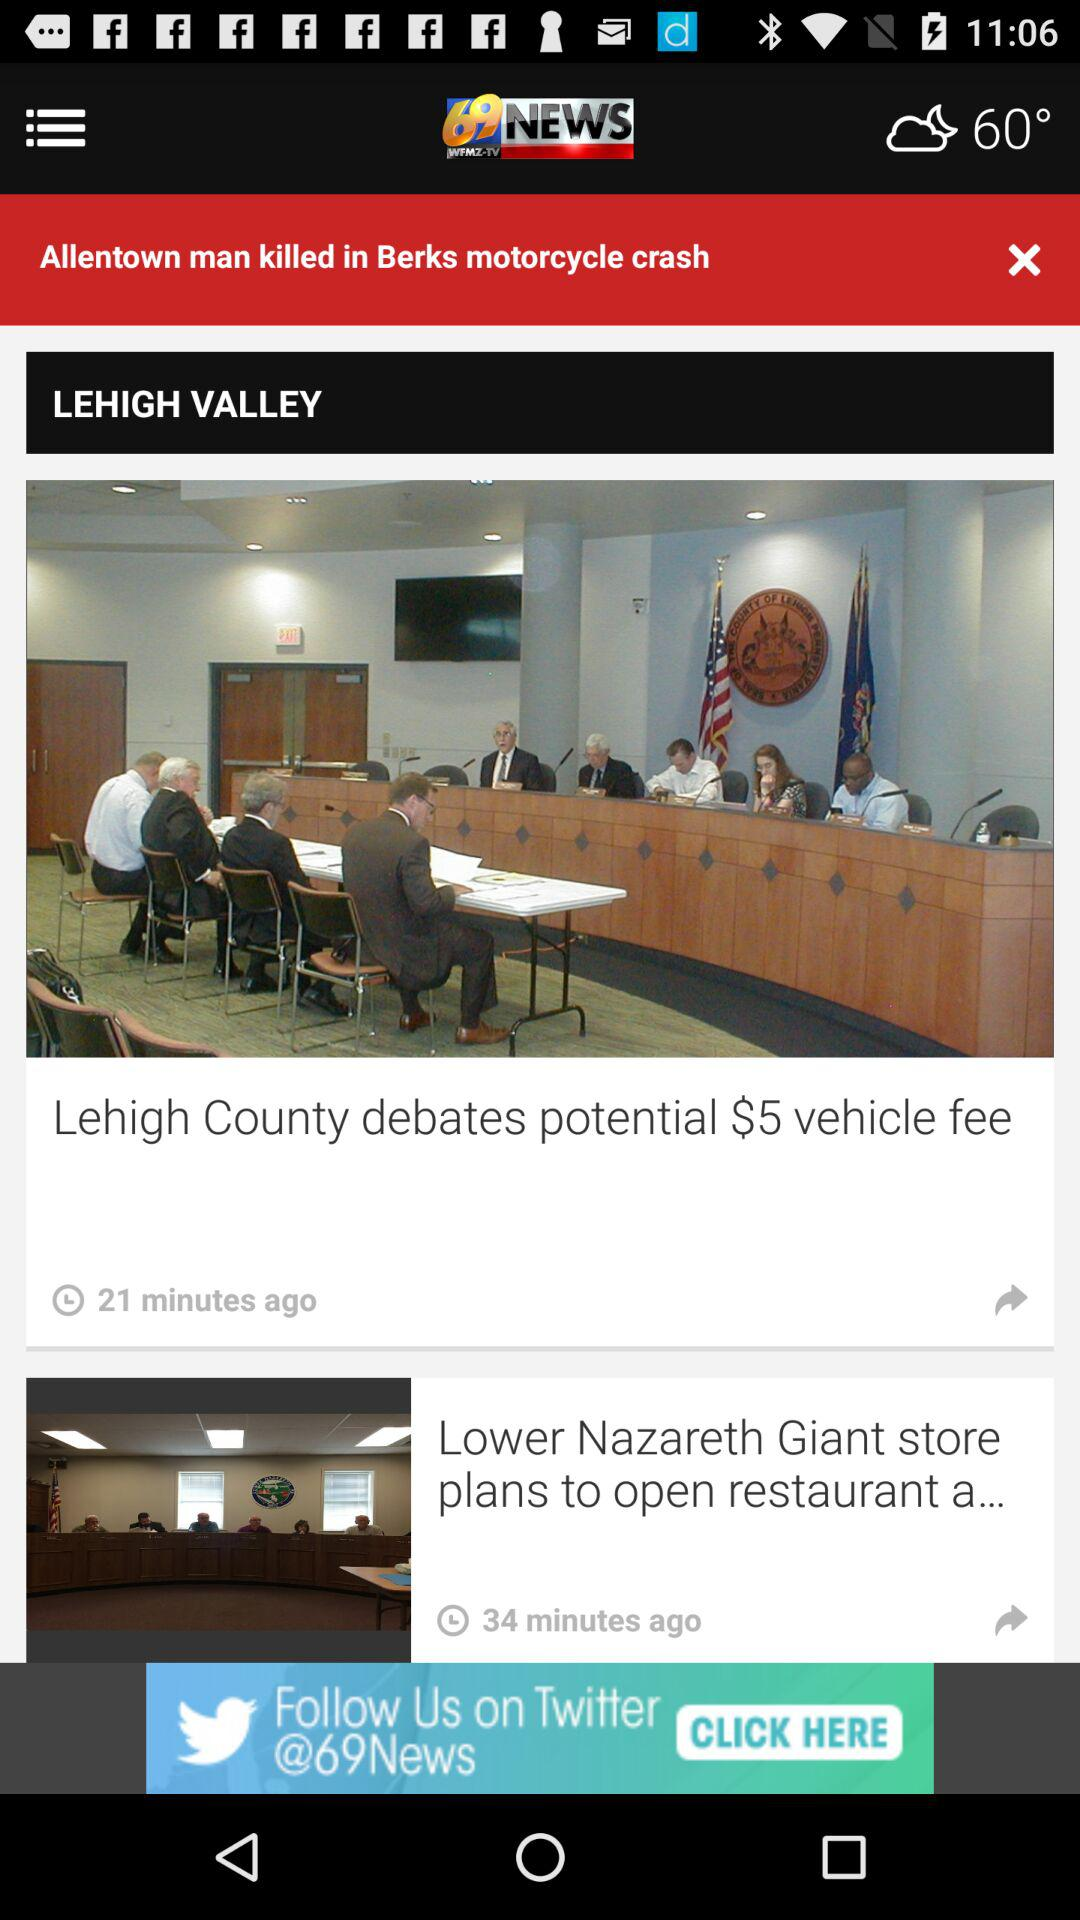What is the name of the application? The name of the application is "WFMZ+ Streaming". 